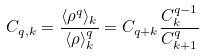Convert formula to latex. <formula><loc_0><loc_0><loc_500><loc_500>C _ { q , k } = \frac { \langle \rho ^ { q } \rangle _ { k } } { \langle \rho \rangle _ { k } ^ { q } } = C _ { q + k } \frac { C _ { k } ^ { q - 1 } } { C _ { k + 1 } ^ { q } }</formula> 